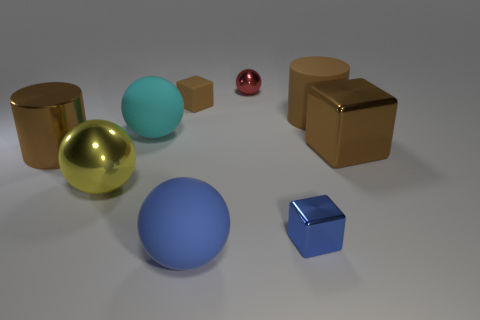Which objects are reflective, and what might that indicate about their material? The gold and silver spheres, along with the copper cubes, are reflective. This suggests that they are likely made of metal, as metals tend to have reflective surfaces that can mirror their surroundings. 